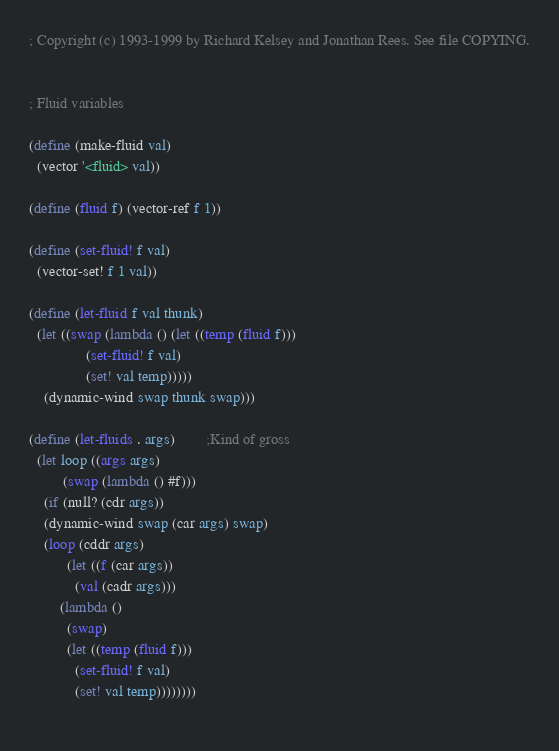Convert code to text. <code><loc_0><loc_0><loc_500><loc_500><_Scheme_>; Copyright (c) 1993-1999 by Richard Kelsey and Jonathan Rees. See file COPYING.


; Fluid variables

(define (make-fluid val)
  (vector '<fluid> val))

(define (fluid f) (vector-ref f 1))

(define (set-fluid! f val)
  (vector-set! f 1 val))

(define (let-fluid f val thunk)
  (let ((swap (lambda () (let ((temp (fluid f)))
			   (set-fluid! f val)
			   (set! val temp)))))
    (dynamic-wind swap thunk swap)))

(define (let-fluids . args)		;Kind of gross
  (let loop ((args args)
	     (swap (lambda () #f)))
    (if (null? (cdr args))
	(dynamic-wind swap (car args) swap)
	(loop (cddr args)
	      (let ((f (car args))
		    (val (cadr args)))
		(lambda ()
		  (swap)
		  (let ((temp (fluid f)))
		    (set-fluid! f val)
		    (set! val temp))))))))
		
</code> 